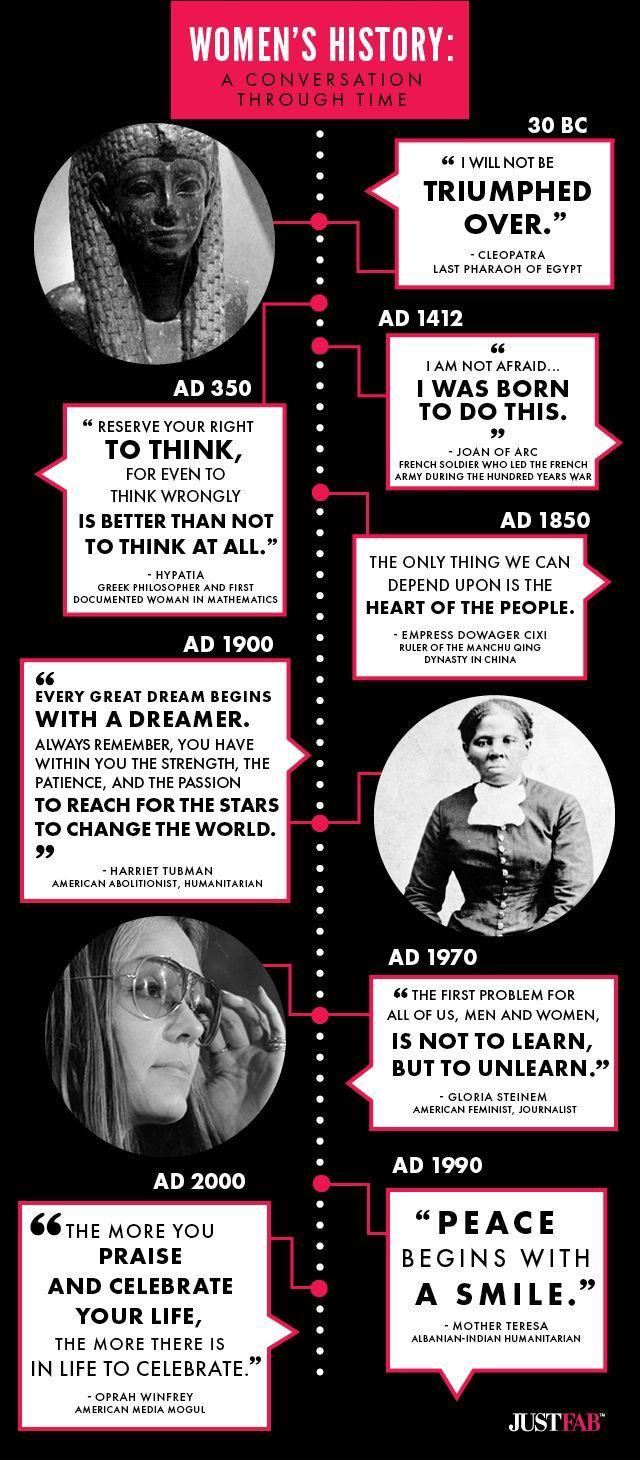Who were the humanitarians in the 20th century?
Answer the question with a short phrase. Harriet Tubman, Mother Teresa Which century was Joan of Arc born, 15th, 16th, 17th or 19th century? 15th century 